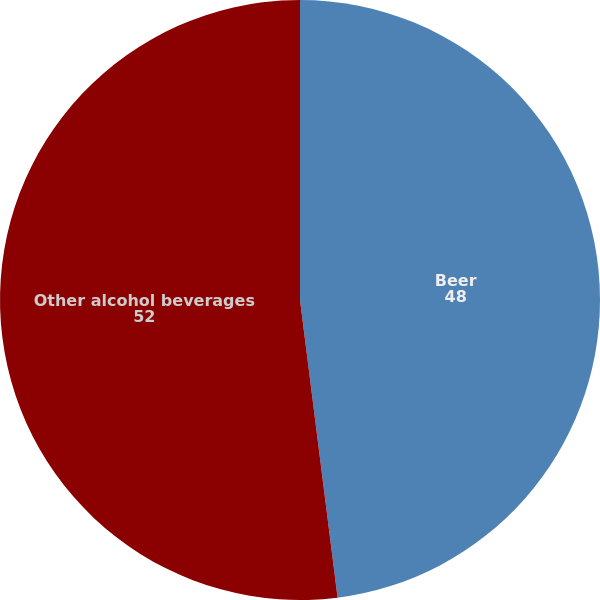Convert chart. <chart><loc_0><loc_0><loc_500><loc_500><pie_chart><fcel>Beer<fcel>Other alcohol beverages<nl><fcel>48.0%<fcel>52.0%<nl></chart> 